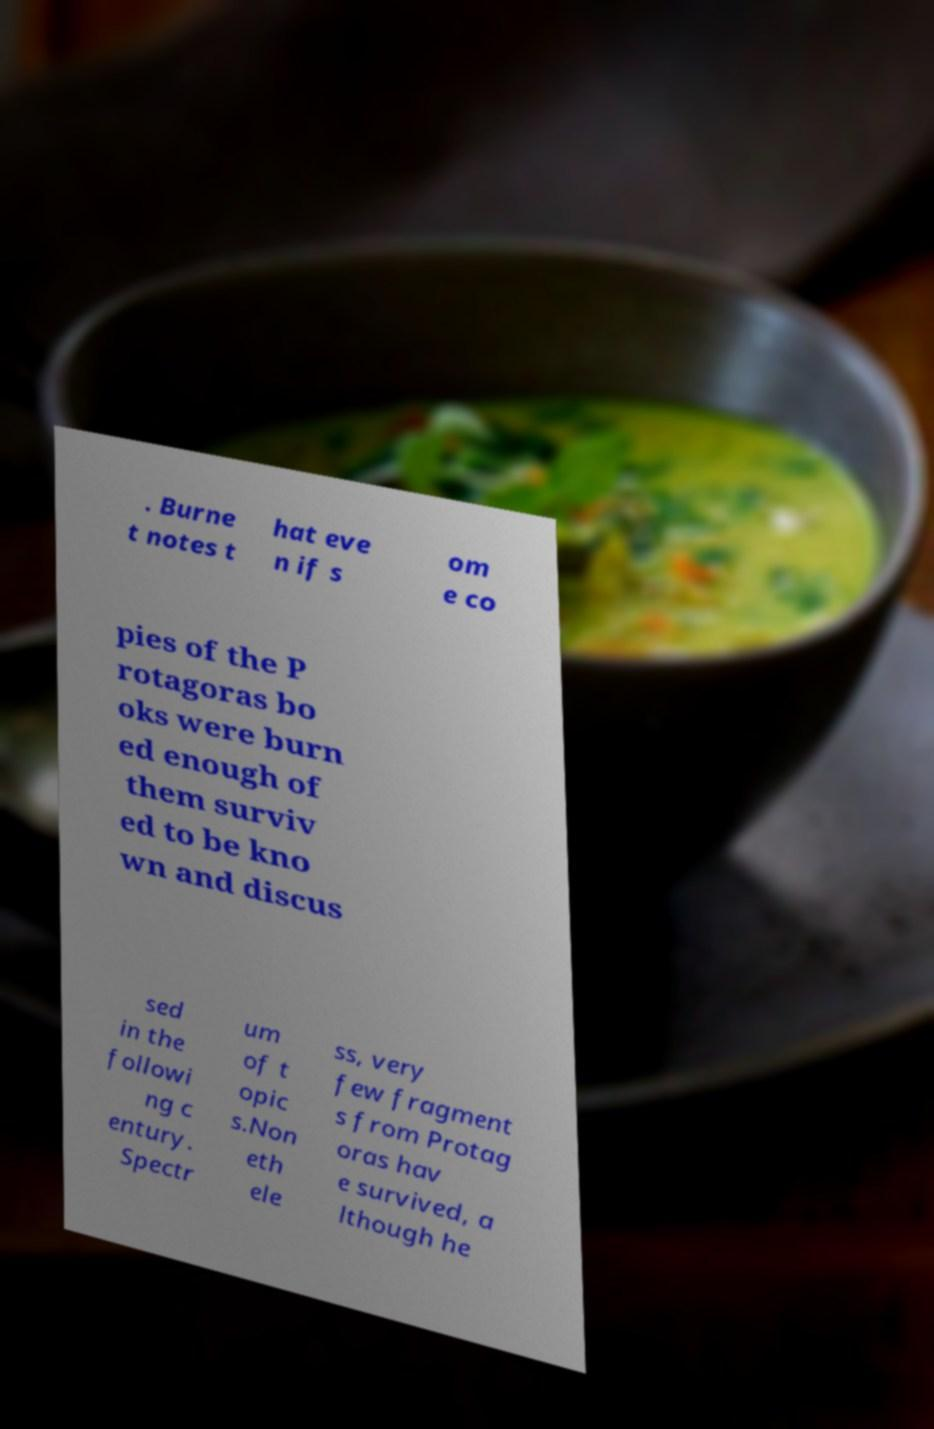I need the written content from this picture converted into text. Can you do that? . Burne t notes t hat eve n if s om e co pies of the P rotagoras bo oks were burn ed enough of them surviv ed to be kno wn and discus sed in the followi ng c entury. Spectr um of t opic s.Non eth ele ss, very few fragment s from Protag oras hav e survived, a lthough he 